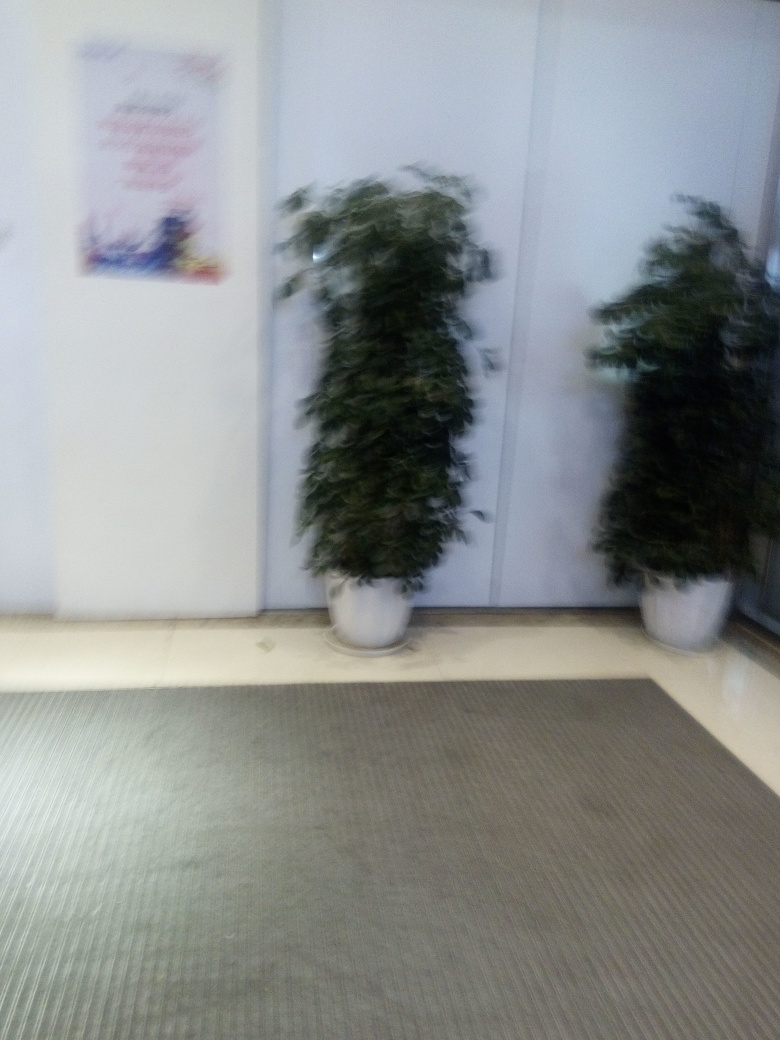What could be the reason for the blur in this image? The blur in this image is most likely due to camera shake or a low shutter speed while taking the photo without a stable base or tripod. It could also be that the autofocus did not lock correctly onto the subjects, which are the two potted plants, resulting in an overall lack of sharpness. 